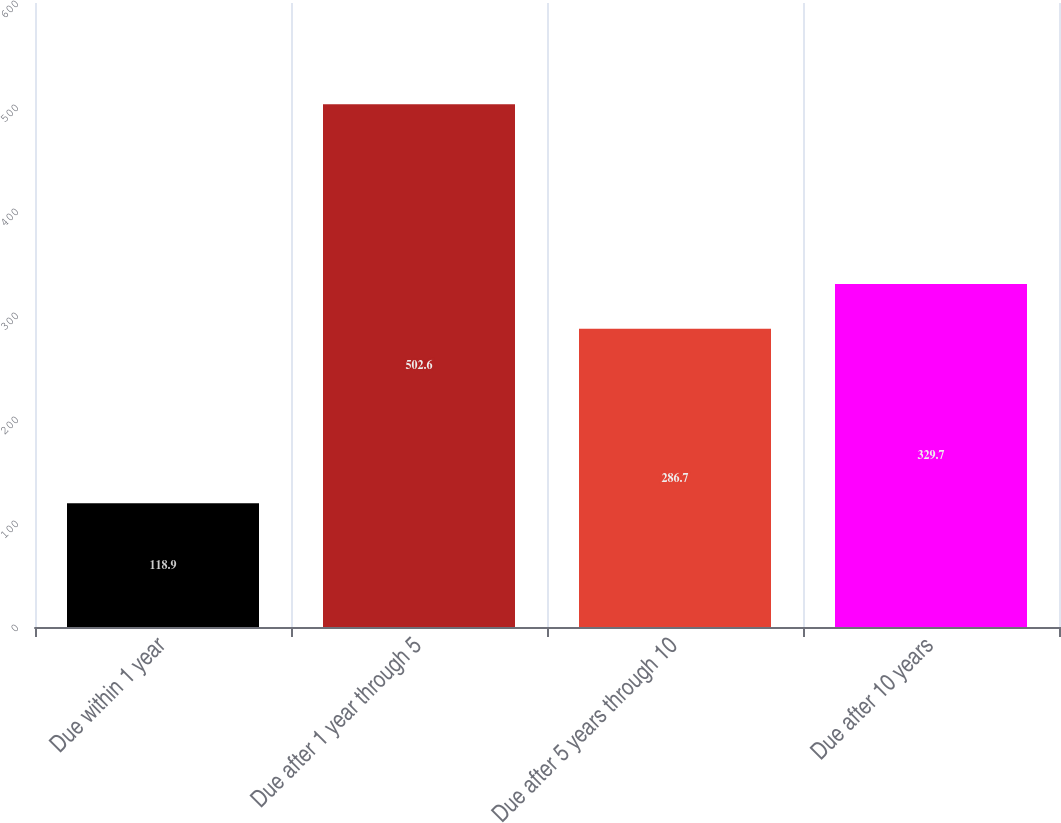<chart> <loc_0><loc_0><loc_500><loc_500><bar_chart><fcel>Due within 1 year<fcel>Due after 1 year through 5<fcel>Due after 5 years through 10<fcel>Due after 10 years<nl><fcel>118.9<fcel>502.6<fcel>286.7<fcel>329.7<nl></chart> 